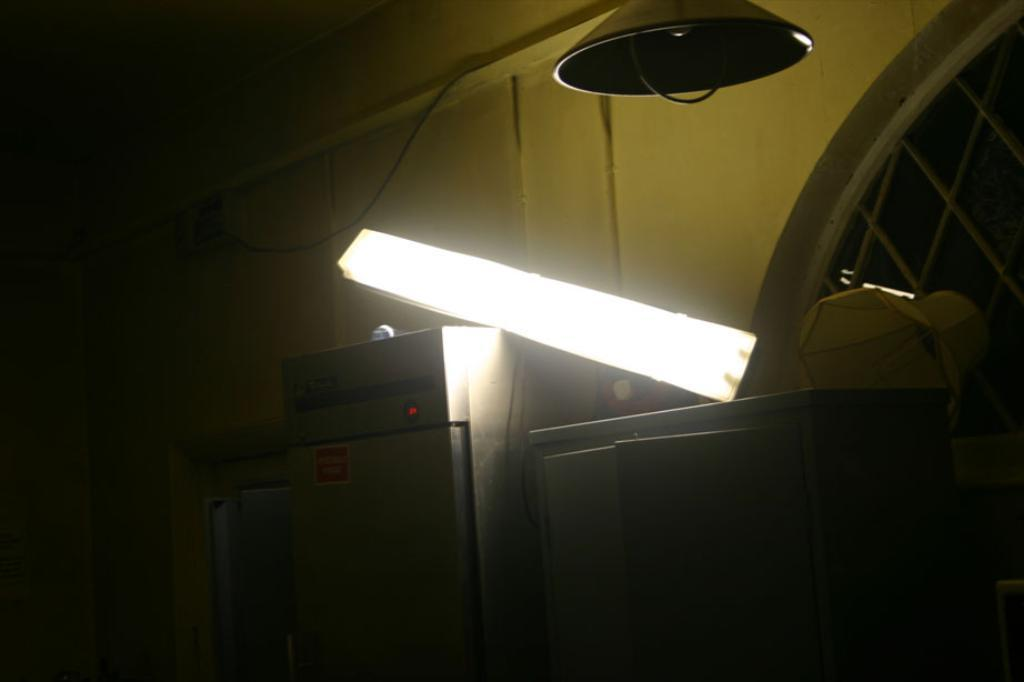What are the two objects with light on the top in the image? Unfortunately, the facts provided do not give a specific description of the objects with light on the top. However, we can confirm that there are two such objects in the image. What is hanging from the ceiling in the image? The facts provided do not specify what is hanging from the ceiling. We can only confirm that there is something hanging from the ceiling in the image. How many chess pieces are attacking each other in the image? There is no mention of chess pieces or any form of attack in the image. The image features two objects with light on the top and something hanging from the ceiling. 